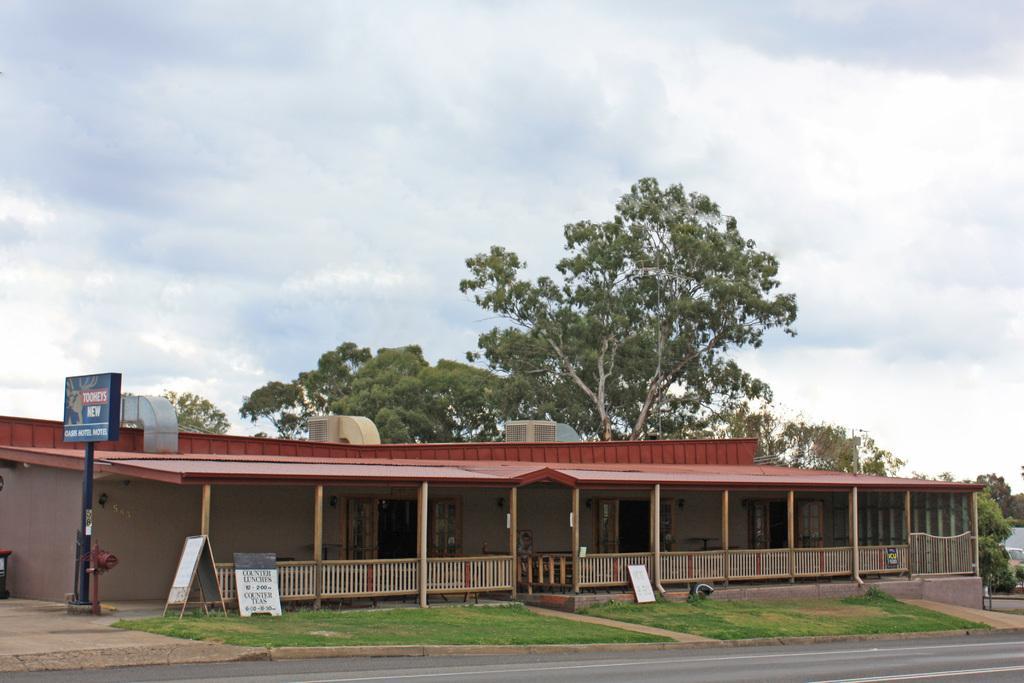Please provide a concise description of this image. In this picture we can see a building, in front of building we can find few hoardings and grass, in the background we can find few trees and clouds. 